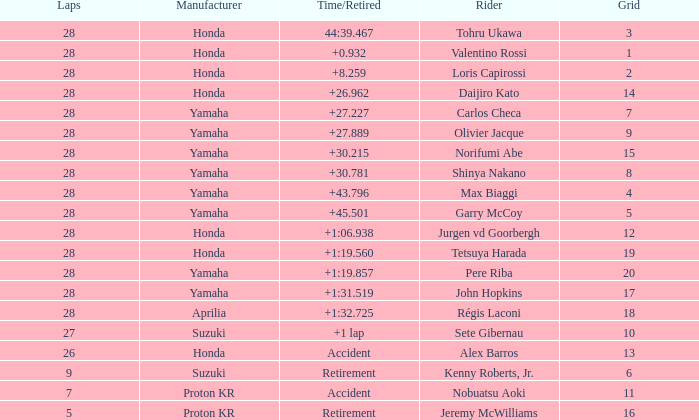Which Grid has Laps larger than 26, and a Time/Retired of 44:39.467? 3.0. 